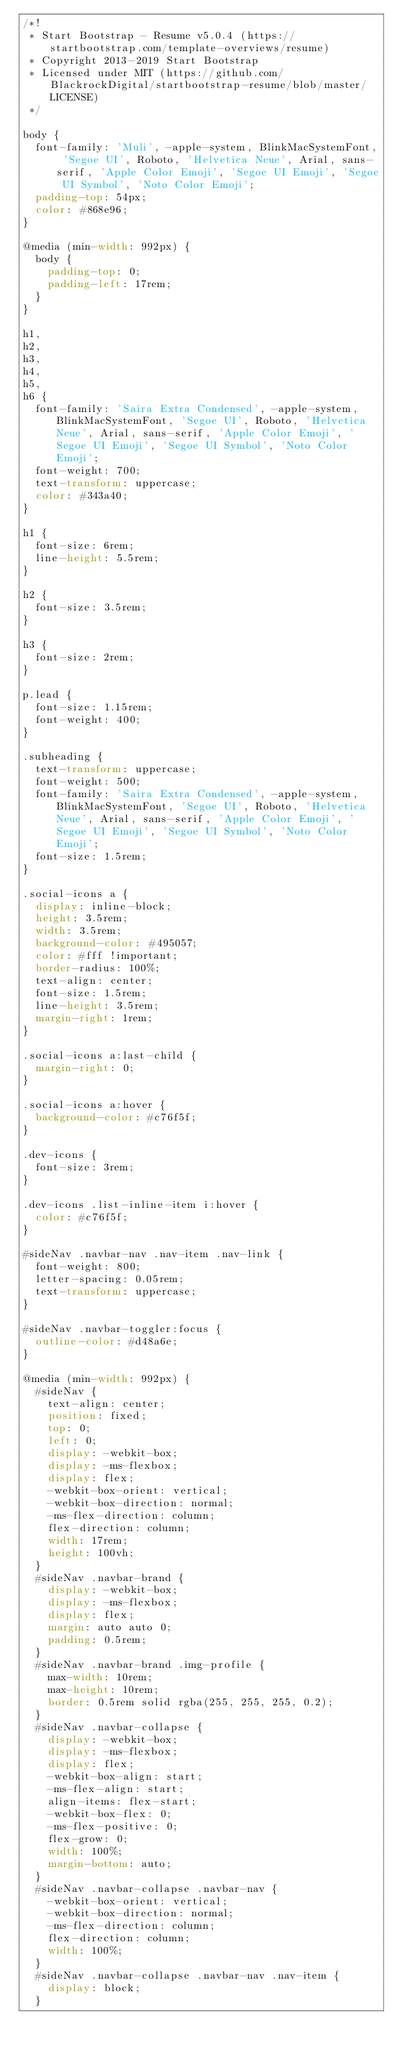<code> <loc_0><loc_0><loc_500><loc_500><_CSS_>/*!
 * Start Bootstrap - Resume v5.0.4 (https://startbootstrap.com/template-overviews/resume)
 * Copyright 2013-2019 Start Bootstrap
 * Licensed under MIT (https://github.com/BlackrockDigital/startbootstrap-resume/blob/master/LICENSE)
 */

body {
  font-family: 'Muli', -apple-system, BlinkMacSystemFont, 'Segoe UI', Roboto, 'Helvetica Neue', Arial, sans-serif, 'Apple Color Emoji', 'Segoe UI Emoji', 'Segoe UI Symbol', 'Noto Color Emoji';
  padding-top: 54px;
  color: #868e96;
}

@media (min-width: 992px) {
  body {
    padding-top: 0;
    padding-left: 17rem;
  }
}

h1,
h2,
h3,
h4,
h5,
h6 {
  font-family: 'Saira Extra Condensed', -apple-system, BlinkMacSystemFont, 'Segoe UI', Roboto, 'Helvetica Neue', Arial, sans-serif, 'Apple Color Emoji', 'Segoe UI Emoji', 'Segoe UI Symbol', 'Noto Color Emoji';
  font-weight: 700;
  text-transform: uppercase;
  color: #343a40;
}

h1 {
  font-size: 6rem;
  line-height: 5.5rem;
}

h2 {
  font-size: 3.5rem;
}

h3 {
  font-size: 2rem;
}

p.lead {
  font-size: 1.15rem;
  font-weight: 400;
}

.subheading {
  text-transform: uppercase;
  font-weight: 500;
  font-family: 'Saira Extra Condensed', -apple-system, BlinkMacSystemFont, 'Segoe UI', Roboto, 'Helvetica Neue', Arial, sans-serif, 'Apple Color Emoji', 'Segoe UI Emoji', 'Segoe UI Symbol', 'Noto Color Emoji';
  font-size: 1.5rem;
}

.social-icons a {
  display: inline-block;
  height: 3.5rem;
  width: 3.5rem;
  background-color: #495057;
  color: #fff !important;
  border-radius: 100%;
  text-align: center;
  font-size: 1.5rem;
  line-height: 3.5rem;
  margin-right: 1rem;
}

.social-icons a:last-child {
  margin-right: 0;
}

.social-icons a:hover {
  background-color: #c76f5f;
}

.dev-icons {
  font-size: 3rem;
}

.dev-icons .list-inline-item i:hover {
  color: #c76f5f;
}

#sideNav .navbar-nav .nav-item .nav-link {
  font-weight: 800;
  letter-spacing: 0.05rem;
  text-transform: uppercase;
}

#sideNav .navbar-toggler:focus {
  outline-color: #d48a6e;
}

@media (min-width: 992px) {
  #sideNav {
    text-align: center;
    position: fixed;
    top: 0;
    left: 0;
    display: -webkit-box;
    display: -ms-flexbox;
    display: flex;
    -webkit-box-orient: vertical;
    -webkit-box-direction: normal;
    -ms-flex-direction: column;
    flex-direction: column;
    width: 17rem;
    height: 100vh;
  }
  #sideNav .navbar-brand {
    display: -webkit-box;
    display: -ms-flexbox;
    display: flex;
    margin: auto auto 0;
    padding: 0.5rem;
  }
  #sideNav .navbar-brand .img-profile {
    max-width: 10rem;
    max-height: 10rem;
    border: 0.5rem solid rgba(255, 255, 255, 0.2);
  }
  #sideNav .navbar-collapse {
    display: -webkit-box;
    display: -ms-flexbox;
    display: flex;
    -webkit-box-align: start;
    -ms-flex-align: start;
    align-items: flex-start;
    -webkit-box-flex: 0;
    -ms-flex-positive: 0;
    flex-grow: 0;
    width: 100%;
    margin-bottom: auto;
  }
  #sideNav .navbar-collapse .navbar-nav {
    -webkit-box-orient: vertical;
    -webkit-box-direction: normal;
    -ms-flex-direction: column;
    flex-direction: column;
    width: 100%;
  }
  #sideNav .navbar-collapse .navbar-nav .nav-item {
    display: block;
  }</code> 